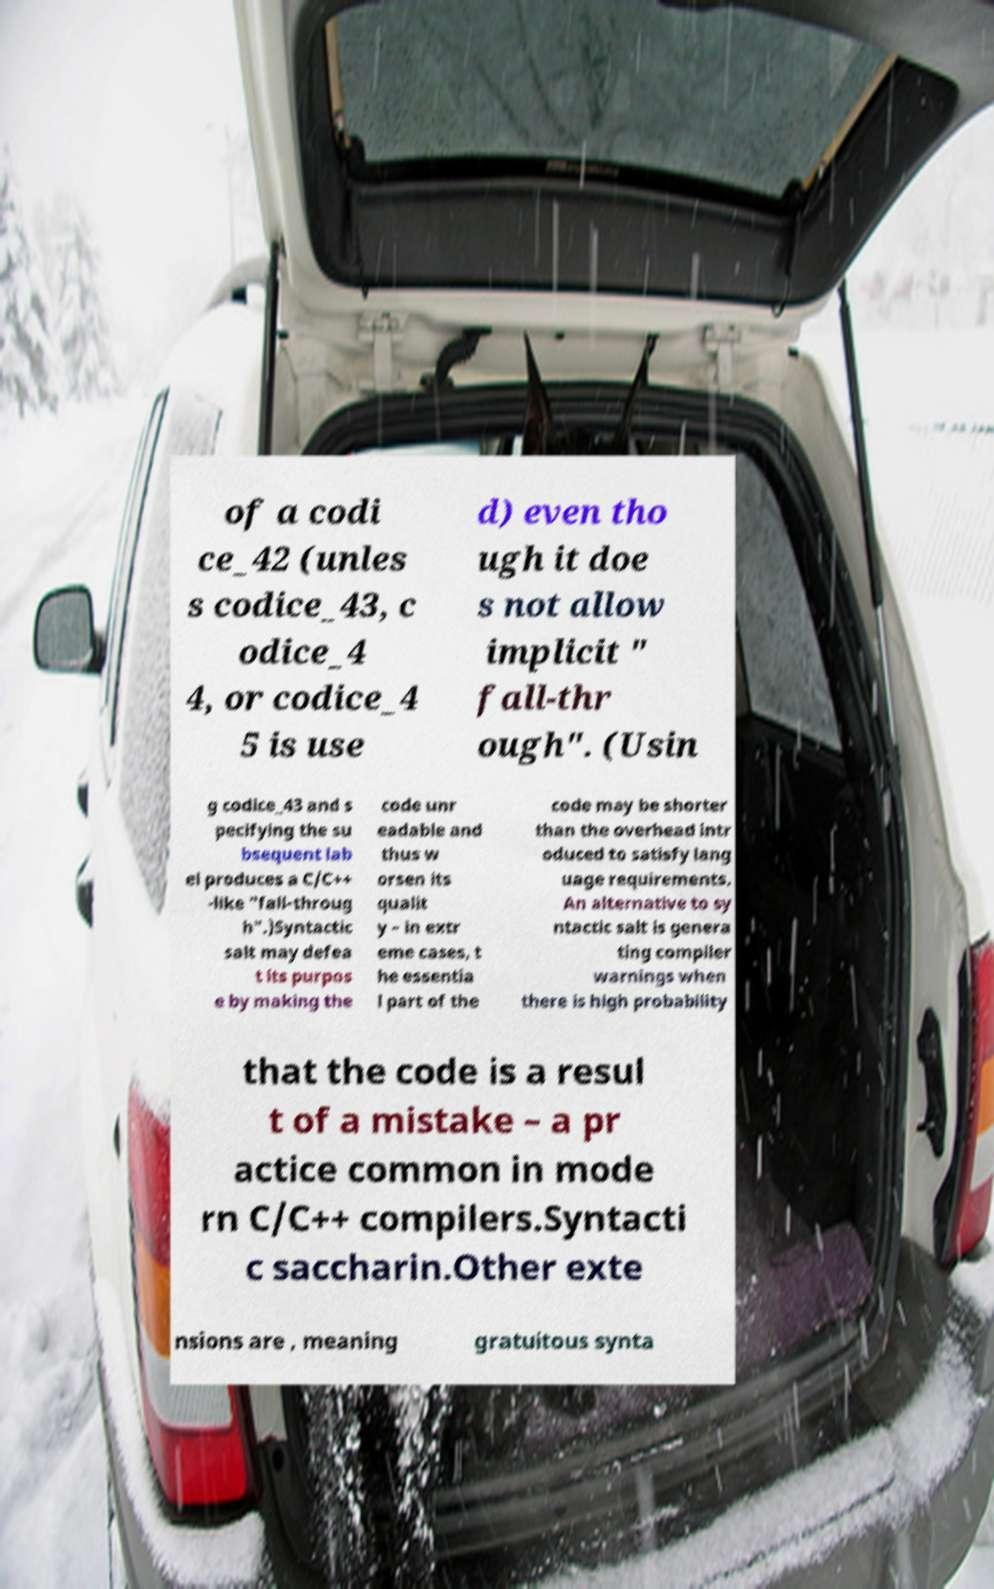Please identify and transcribe the text found in this image. of a codi ce_42 (unles s codice_43, c odice_4 4, or codice_4 5 is use d) even tho ugh it doe s not allow implicit " fall-thr ough". (Usin g codice_43 and s pecifying the su bsequent lab el produces a C/C++ -like "fall-throug h".)Syntactic salt may defea t its purpos e by making the code unr eadable and thus w orsen its qualit y – in extr eme cases, t he essentia l part of the code may be shorter than the overhead intr oduced to satisfy lang uage requirements. An alternative to sy ntactic salt is genera ting compiler warnings when there is high probability that the code is a resul t of a mistake – a pr actice common in mode rn C/C++ compilers.Syntacti c saccharin.Other exte nsions are , meaning gratuitous synta 